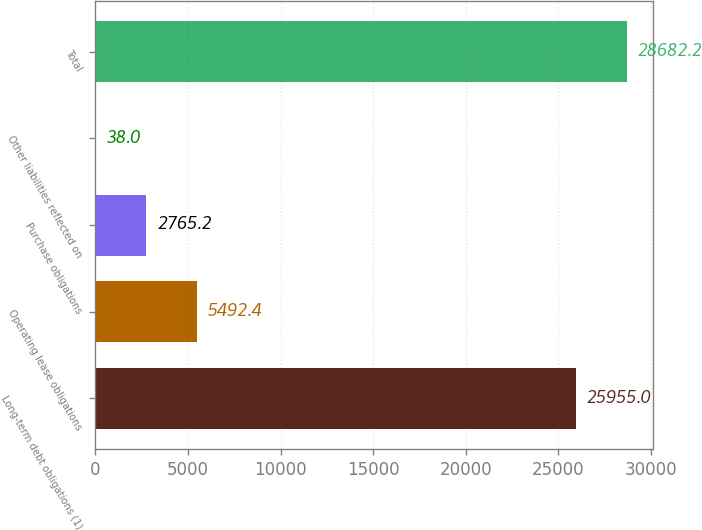Convert chart. <chart><loc_0><loc_0><loc_500><loc_500><bar_chart><fcel>Long-term debt obligations (1)<fcel>Operating lease obligations<fcel>Purchase obligations<fcel>Other liabilities reflected on<fcel>Total<nl><fcel>25955<fcel>5492.4<fcel>2765.2<fcel>38<fcel>28682.2<nl></chart> 